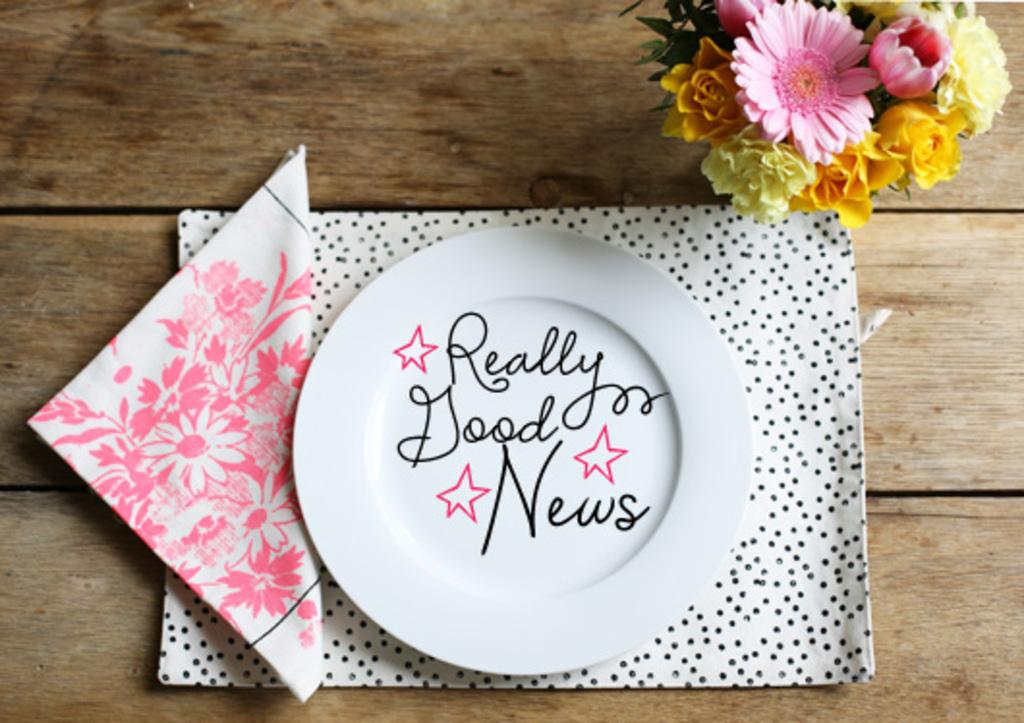<image>
Share a concise interpretation of the image provided. a plate that says 'really good news' on it in cursive 